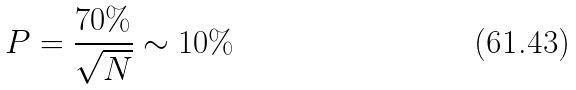Convert formula to latex. <formula><loc_0><loc_0><loc_500><loc_500>P = \frac { 7 0 \% } { \sqrt { N } } \sim 1 0 \%</formula> 